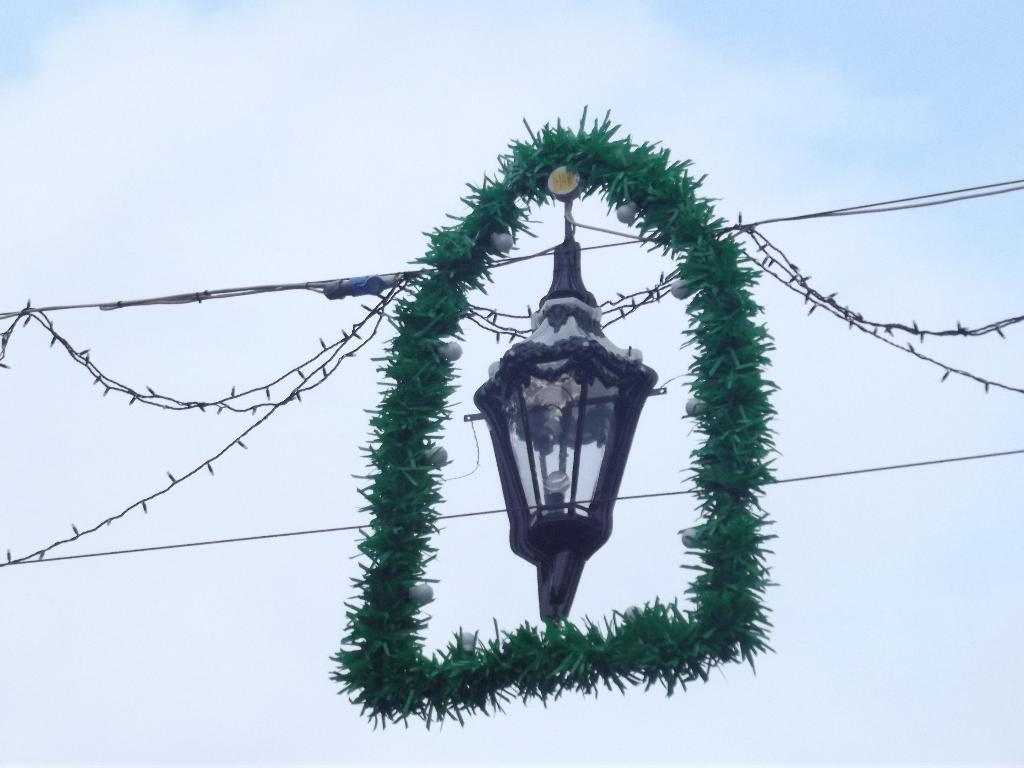What object in the image has a ribbon attached to it? There is a lamp with a ribbon in the image. What else can be seen in the image related to electricity or wiring? There are wires visible in the image. What type of lighting is present in the image besides the lamp? There are ceiling lights in the image. What can be seen in the background of the image? The sky is visible in the image, and it appears cloudy. What type of juice is being served in the image? There is no juice present in the image. Can you see a toothbrush in the image? No, there is no toothbrush present in the image. 